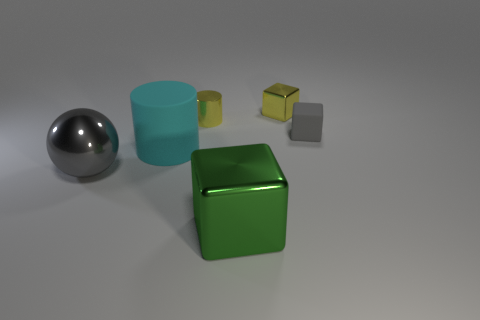What is the shape of the small thing that is both right of the yellow cylinder and left of the tiny rubber object?
Ensure brevity in your answer.  Cube. There is a tiny rubber cube; is its color the same as the cube in front of the rubber cylinder?
Ensure brevity in your answer.  No. There is a metallic object that is to the left of the cyan rubber cylinder; does it have the same size as the gray block?
Your response must be concise. No. There is a tiny yellow object that is the same shape as the large cyan rubber thing; what is its material?
Your response must be concise. Metal. Is the large rubber object the same shape as the small gray matte object?
Make the answer very short. No. What number of gray balls are behind the metallic thing that is behind the metal cylinder?
Give a very brief answer. 0. What is the shape of the big thing that is the same material as the tiny gray cube?
Keep it short and to the point. Cylinder. How many cyan things are either big matte things or tiny rubber objects?
Make the answer very short. 1. There is a tiny shiny thing that is to the left of the small block that is left of the gray block; are there any matte cubes that are behind it?
Provide a short and direct response. No. Is the number of cyan shiny spheres less than the number of big things?
Make the answer very short. Yes. 